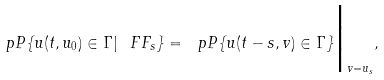Convert formula to latex. <formula><loc_0><loc_0><loc_500><loc_500>\ p P \{ u ( t , u _ { 0 } ) \in \Gamma | \ F F _ { s } \} = \ p P \{ u ( t - s , v ) \in \Gamma \} \Big | _ { v = u _ { s } } ,</formula> 